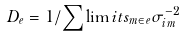<formula> <loc_0><loc_0><loc_500><loc_500>D _ { e } = 1 / \sum \lim i t s _ { m \in e } \sigma _ { i m } ^ { - 2 }</formula> 